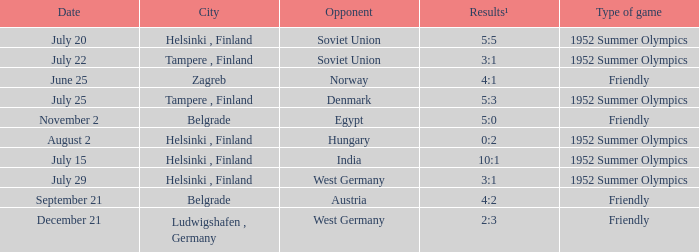What was the genre of the game played on july 29? 1952 Summer Olympics. I'm looking to parse the entire table for insights. Could you assist me with that? {'header': ['Date', 'City', 'Opponent', 'Results¹', 'Type of game'], 'rows': [['July 20', 'Helsinki , Finland', 'Soviet Union', '5:5', '1952 Summer Olympics'], ['July 22', 'Tampere , Finland', 'Soviet Union', '3:1', '1952 Summer Olympics'], ['June 25', 'Zagreb', 'Norway', '4:1', 'Friendly'], ['July 25', 'Tampere , Finland', 'Denmark', '5:3', '1952 Summer Olympics'], ['November 2', 'Belgrade', 'Egypt', '5:0', 'Friendly'], ['August 2', 'Helsinki , Finland', 'Hungary', '0:2', '1952 Summer Olympics'], ['July 15', 'Helsinki , Finland', 'India', '10:1', '1952 Summer Olympics'], ['July 29', 'Helsinki , Finland', 'West Germany', '3:1', '1952 Summer Olympics'], ['September 21', 'Belgrade', 'Austria', '4:2', 'Friendly'], ['December 21', 'Ludwigshafen , Germany', 'West Germany', '2:3', 'Friendly']]} 